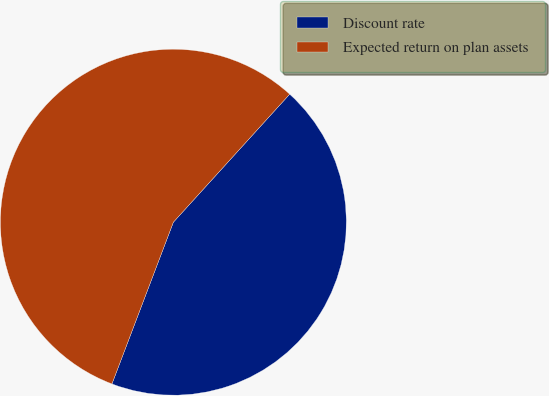Convert chart to OTSL. <chart><loc_0><loc_0><loc_500><loc_500><pie_chart><fcel>Discount rate<fcel>Expected return on plan assets<nl><fcel>44.04%<fcel>55.96%<nl></chart> 